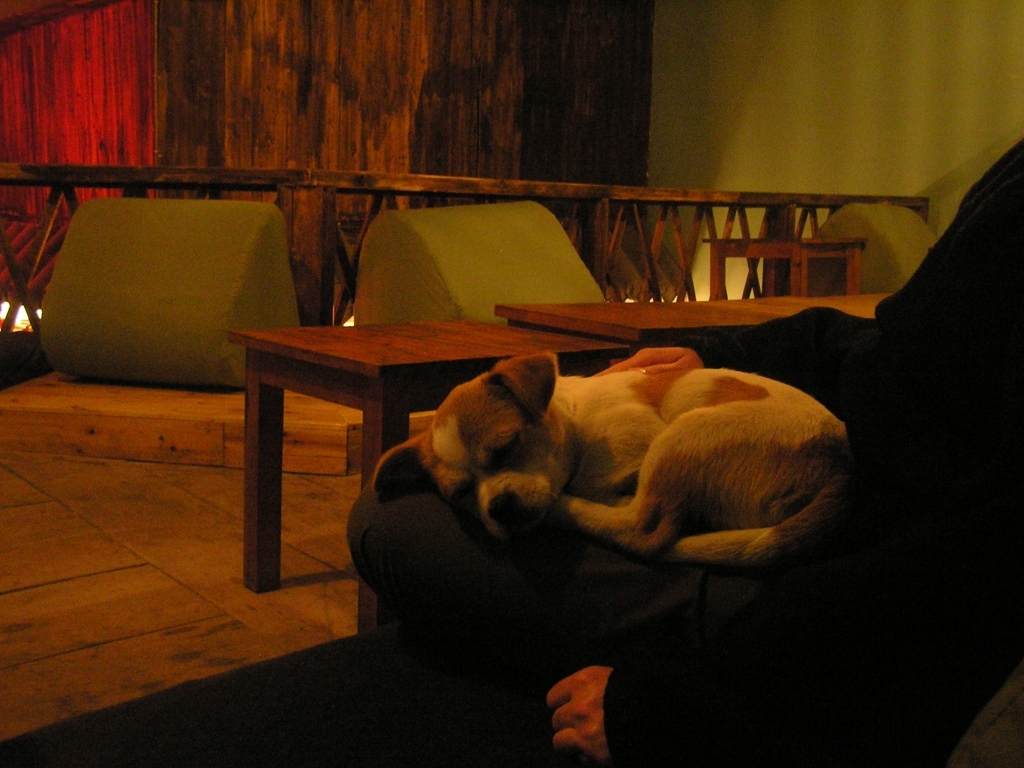Are there severe noise points in this photo? Upon closer examination, the photo does exhibit some graininess, particularly noticeable in the darker areas which could be characterized as mild noise. However, it doesn't appear to significantly detract from the central subject of the image, which is the resting dog. 